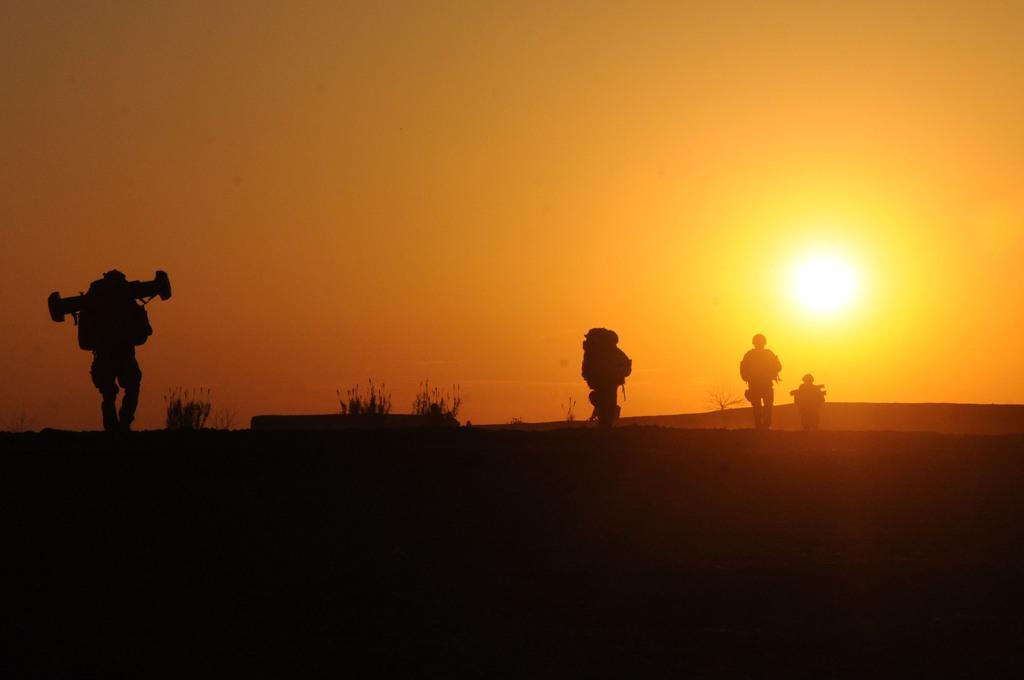Could you give a brief overview of what you see in this image? On the left side, there is a person walking on the ground, on which there are plants. On the right side, there are three persons on the ground. In the background, there is a sun in the sky. 